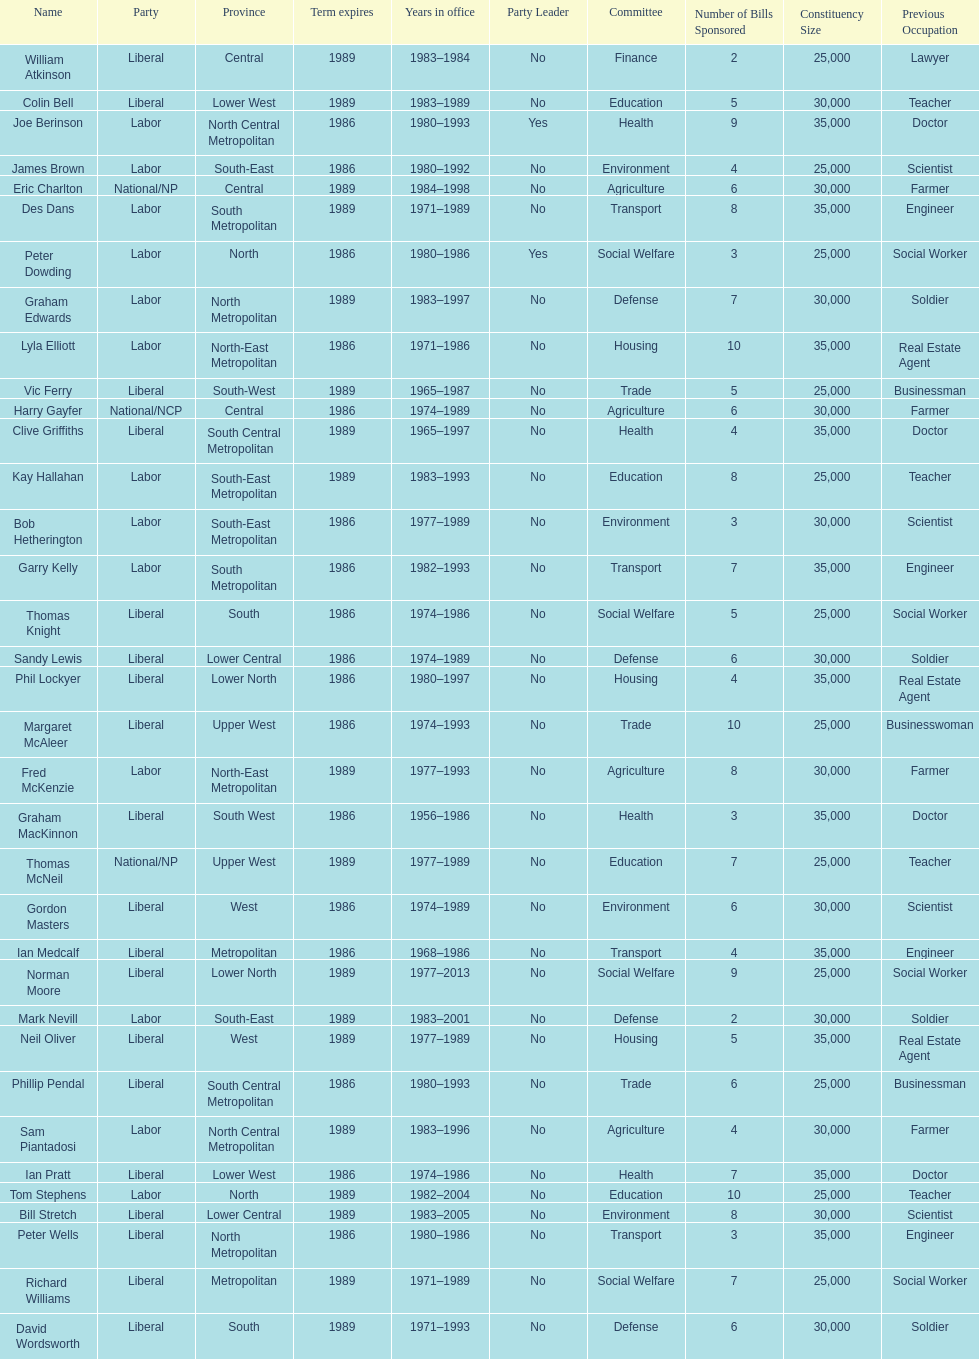What is the total number of members whose term expires in 1989? 9. 